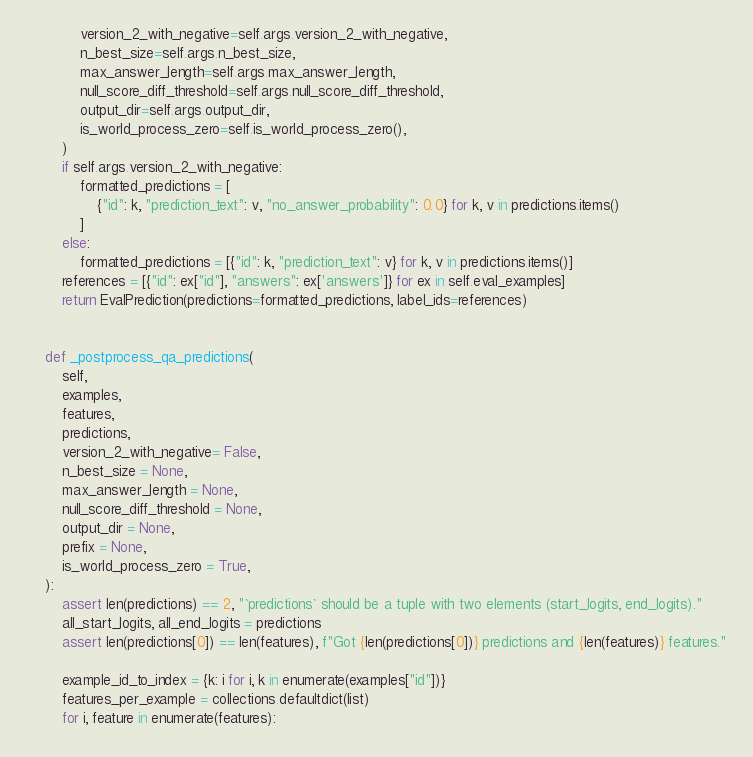<code> <loc_0><loc_0><loc_500><loc_500><_Python_>            version_2_with_negative=self.args.version_2_with_negative,
            n_best_size=self.args.n_best_size,
            max_answer_length=self.args.max_answer_length,
            null_score_diff_threshold=self.args.null_score_diff_threshold,
            output_dir=self.args.output_dir,
            is_world_process_zero=self.is_world_process_zero(),
        )
        if self.args.version_2_with_negative:
            formatted_predictions = [
                {"id": k, "prediction_text": v, "no_answer_probability": 0.0} for k, v in predictions.items()
            ]
        else:
            formatted_predictions = [{"id": k, "prediction_text": v} for k, v in predictions.items()]
        references = [{"id": ex["id"], "answers": ex['answers']} for ex in self.eval_examples]
        return EvalPrediction(predictions=formatted_predictions, label_ids=references)


    def _postprocess_qa_predictions(
        self,
        examples,
        features,
        predictions,
        version_2_with_negative= False,
        n_best_size = None,
        max_answer_length = None,
        null_score_diff_threshold = None,
        output_dir = None,
        prefix = None,
        is_world_process_zero = True,
    ):
        assert len(predictions) == 2, "`predictions` should be a tuple with two elements (start_logits, end_logits)."
        all_start_logits, all_end_logits = predictions
        assert len(predictions[0]) == len(features), f"Got {len(predictions[0])} predictions and {len(features)} features."

        example_id_to_index = {k: i for i, k in enumerate(examples["id"])}
        features_per_example = collections.defaultdict(list)
        for i, feature in enumerate(features):</code> 